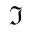Convert formula to latex. <formula><loc_0><loc_0><loc_500><loc_500>\Im</formula> 